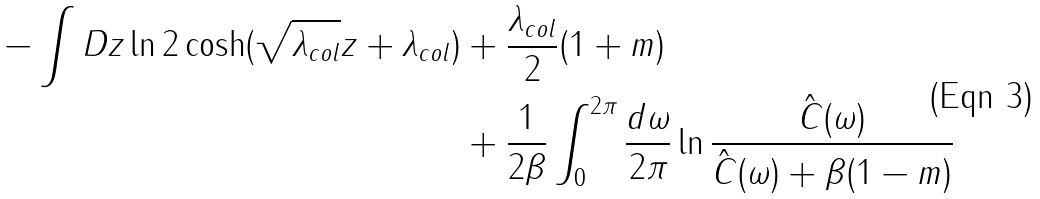<formula> <loc_0><loc_0><loc_500><loc_500>- \int D z \ln 2 \cosh ( \sqrt { \lambda _ { c o l } } z + \lambda _ { c o l } ) & + \frac { \lambda _ { c o l } } { 2 } ( 1 + m ) \\ & + \frac { 1 } { 2 \beta } \int _ { 0 } ^ { 2 \pi } \frac { d \omega } { 2 \pi } \ln \frac { \hat { C } ( \omega ) } { \hat { C } ( \omega ) + \beta ( 1 - m ) }</formula> 